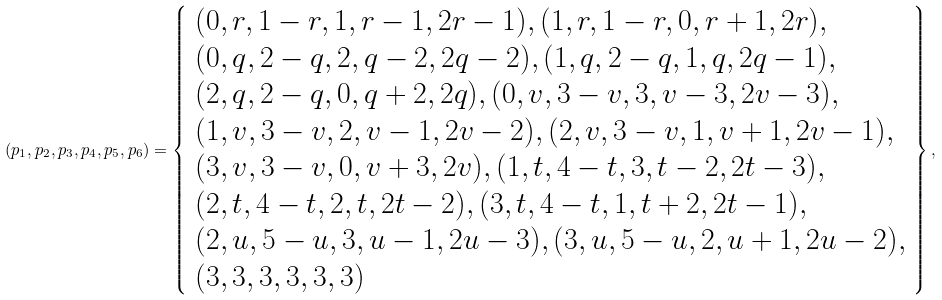Convert formula to latex. <formula><loc_0><loc_0><loc_500><loc_500>( p _ { 1 } , p _ { 2 } , p _ { 3 } , p _ { 4 } , p _ { 5 } , p _ { 6 } ) = \left \{ \begin{array} { l } ( 0 , r , 1 - r , 1 , r - 1 , 2 r - 1 ) , ( 1 , r , 1 - r , 0 , r + 1 , 2 r ) , \\ ( 0 , q , 2 - q , 2 , q - 2 , 2 q - 2 ) , ( 1 , q , 2 - q , 1 , q , 2 q - 1 ) , \\ ( 2 , q , 2 - q , 0 , q + 2 , 2 q ) , ( 0 , v , 3 - v , 3 , v - 3 , 2 v - 3 ) , \\ ( 1 , v , 3 - v , 2 , v - 1 , 2 v - 2 ) , ( 2 , v , 3 - v , 1 , v + 1 , 2 v - 1 ) , \\ ( 3 , v , 3 - v , 0 , v + 3 , 2 v ) , ( 1 , t , 4 - t , 3 , t - 2 , 2 t - 3 ) , \\ ( 2 , t , 4 - t , 2 , t , 2 t - 2 ) , ( 3 , t , 4 - t , 1 , t + 2 , 2 t - 1 ) , \\ ( 2 , u , 5 - u , 3 , u - 1 , 2 u - 3 ) , ( 3 , u , 5 - u , 2 , u + 1 , 2 u - 2 ) , \\ ( 3 , 3 , 3 , 3 , 3 , 3 ) \end{array} \right \} ,</formula> 